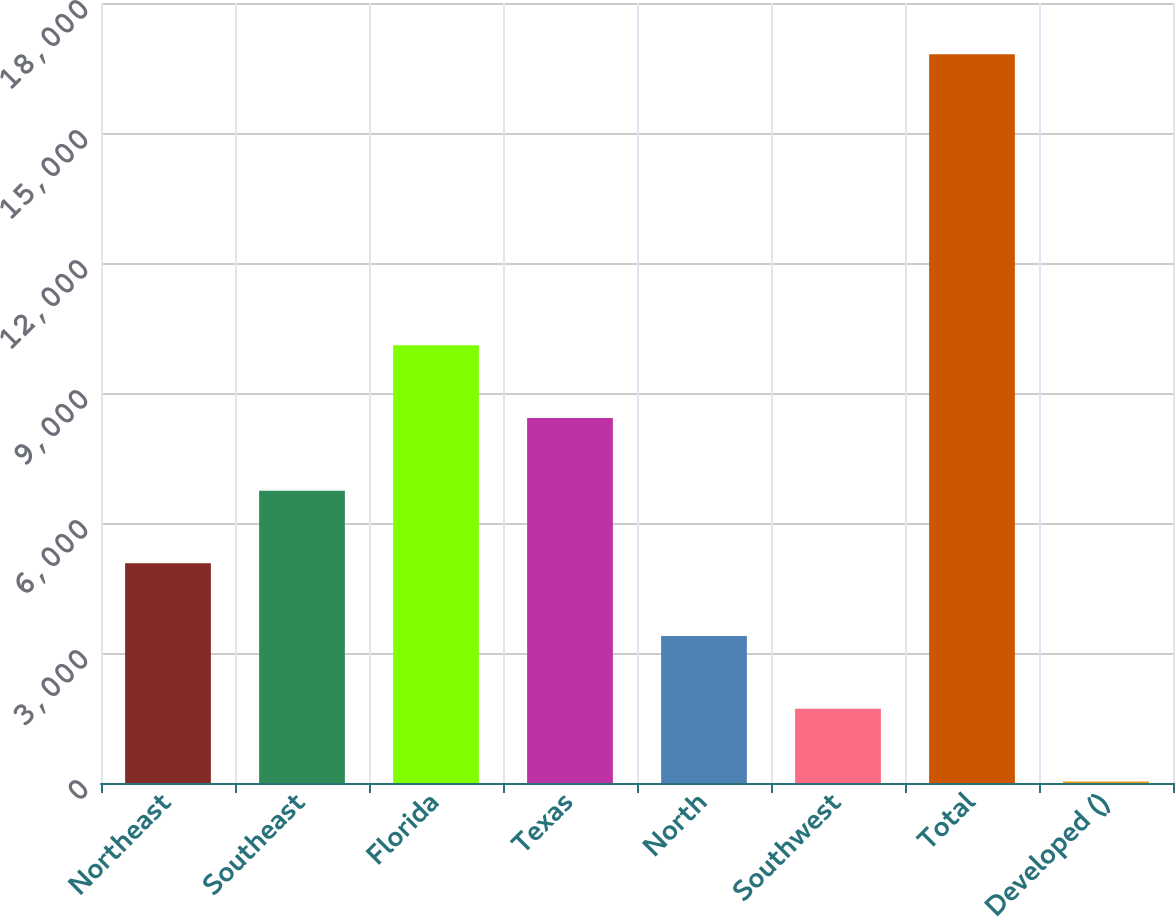Convert chart. <chart><loc_0><loc_0><loc_500><loc_500><bar_chart><fcel>Northeast<fcel>Southeast<fcel>Florida<fcel>Texas<fcel>North<fcel>Southwest<fcel>Total<fcel>Developed ()<nl><fcel>5068.3<fcel>6746.4<fcel>10102.6<fcel>8424.5<fcel>3390.2<fcel>1712.1<fcel>16815<fcel>34<nl></chart> 